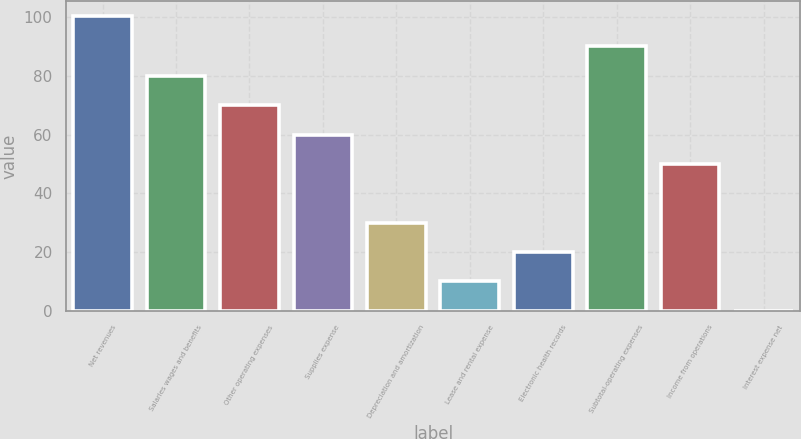<chart> <loc_0><loc_0><loc_500><loc_500><bar_chart><fcel>Net revenues<fcel>Salaries wages and benefits<fcel>Other operating expenses<fcel>Supplies expense<fcel>Depreciation and amortization<fcel>Lease and rental expense<fcel>Electronic health records<fcel>Subtotal-operating expenses<fcel>Income from operations<fcel>Interest expense net<nl><fcel>100.29<fcel>80.02<fcel>70.03<fcel>60.04<fcel>30.07<fcel>10.09<fcel>20.08<fcel>90.3<fcel>50.05<fcel>0.1<nl></chart> 